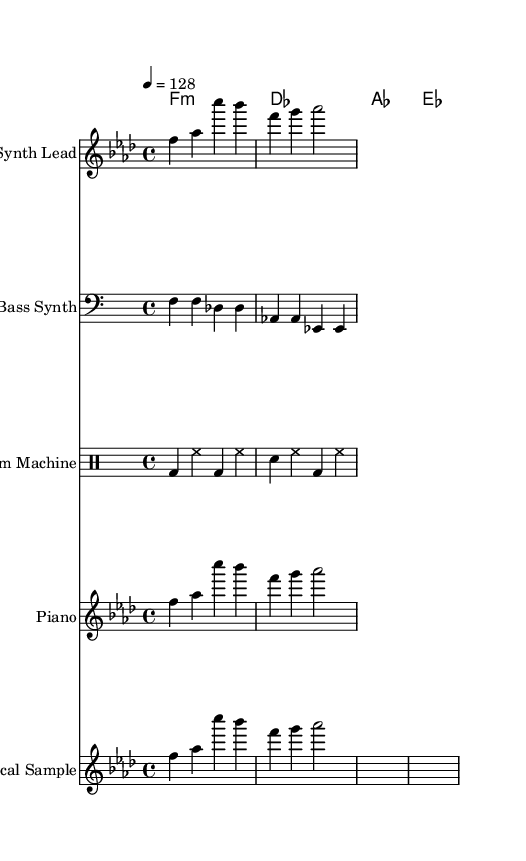What is the key signature of this music? The key signature is F minor, which has four flats (B♭, E♭, A♭, D♭). This can be derived from the initial indication of the key in the global section of the code.
Answer: F minor What is the time signature of this music? The time signature is 4/4, which indicates that there are four beats in each measure and the quarter note gets one beat. This information is found in the global section of the code as well.
Answer: 4/4 What is the tempo marking for this piece? The tempo marking is quarter note equals 128, which means that the tempo or speed of the piece is set at 128 beats per minute. This is specified in the global section of the code.
Answer: 128 How many measures are in the melody part? The melody part contains two measures, as indicated by the presence of two bars in the melody line within the code. Counting the bars will show the total number of measures present.
Answer: 2 Is there a vocal sample included in this music? Yes, there is a vocal sample included, which is indicated by the presence of the lyric mode section that follows the melody and shows the lyrics "Education for all, not just the privileged few." This confirms the inclusion of vocal samples.
Answer: Yes What instruments are utilized in this composition? The instruments used in this composition include Synth Lead, Bass Synth, Drum Machine, and Piano as indicated in the respective staff labels in the score. Based on the mentioned instruments, we can list them accordingly.
Answer: Synth Lead, Bass Synth, Drum Machine, Piano What type of drum pattern is used? The drum pattern used is a basic four-beat pattern, consisting of bass drum (bd), snare drum (sn), and hi-hat (hh), as shown in the drum mode section of the code. The pattern alternates between bass and hi-hat sounds with snare beats as well.
Answer: Four-beat pattern 